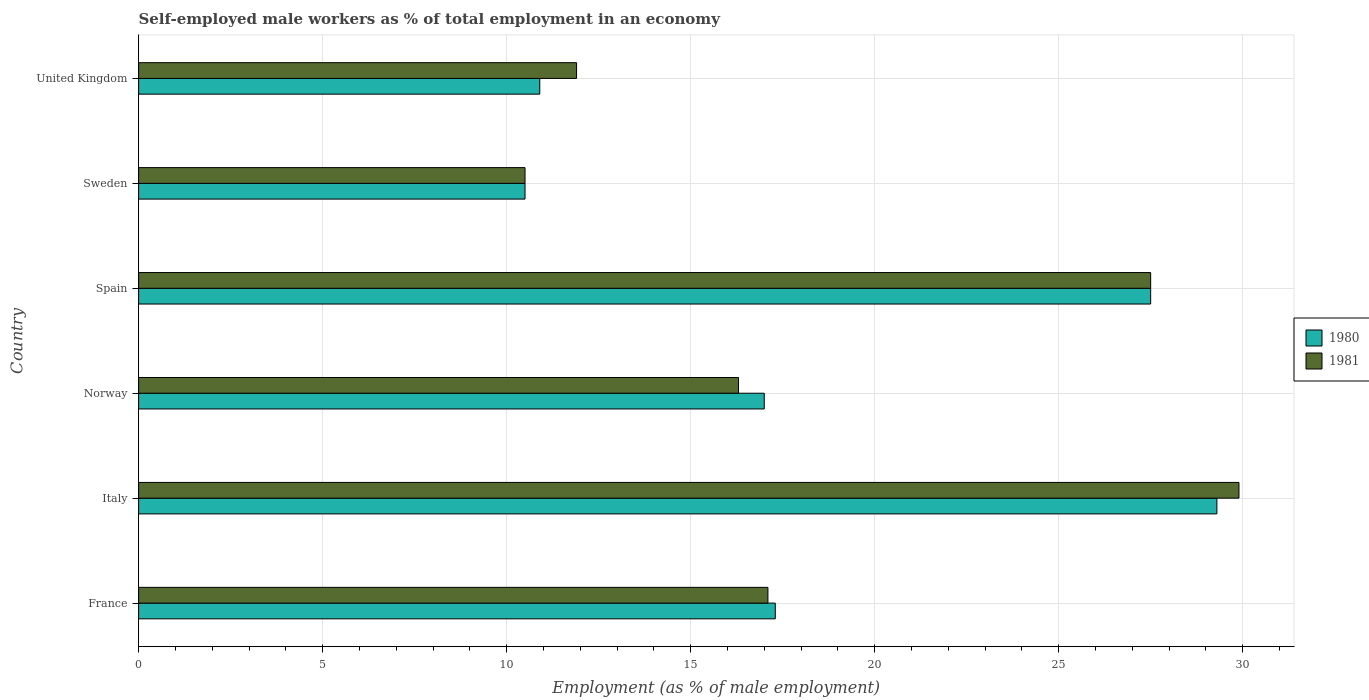How many groups of bars are there?
Your answer should be very brief. 6. How many bars are there on the 5th tick from the top?
Offer a very short reply. 2. How many bars are there on the 1st tick from the bottom?
Keep it short and to the point. 2. In how many cases, is the number of bars for a given country not equal to the number of legend labels?
Provide a short and direct response. 0. What is the percentage of self-employed male workers in 1980 in Norway?
Make the answer very short. 17. Across all countries, what is the maximum percentage of self-employed male workers in 1981?
Your answer should be very brief. 29.9. Across all countries, what is the minimum percentage of self-employed male workers in 1980?
Provide a short and direct response. 10.5. In which country was the percentage of self-employed male workers in 1981 maximum?
Offer a terse response. Italy. In which country was the percentage of self-employed male workers in 1981 minimum?
Offer a terse response. Sweden. What is the total percentage of self-employed male workers in 1980 in the graph?
Offer a terse response. 112.5. What is the difference between the percentage of self-employed male workers in 1980 in Italy and that in Norway?
Keep it short and to the point. 12.3. What is the difference between the percentage of self-employed male workers in 1981 in Norway and the percentage of self-employed male workers in 1980 in France?
Your answer should be very brief. -1. What is the average percentage of self-employed male workers in 1980 per country?
Offer a terse response. 18.75. What is the ratio of the percentage of self-employed male workers in 1980 in Italy to that in United Kingdom?
Your response must be concise. 2.69. Is the percentage of self-employed male workers in 1981 in Italy less than that in Spain?
Your response must be concise. No. What is the difference between the highest and the second highest percentage of self-employed male workers in 1981?
Offer a terse response. 2.4. What is the difference between the highest and the lowest percentage of self-employed male workers in 1980?
Offer a very short reply. 18.8. In how many countries, is the percentage of self-employed male workers in 1981 greater than the average percentage of self-employed male workers in 1981 taken over all countries?
Keep it short and to the point. 2. Is the sum of the percentage of self-employed male workers in 1980 in France and Italy greater than the maximum percentage of self-employed male workers in 1981 across all countries?
Your answer should be compact. Yes. Are all the bars in the graph horizontal?
Give a very brief answer. Yes. How many countries are there in the graph?
Keep it short and to the point. 6. What is the difference between two consecutive major ticks on the X-axis?
Make the answer very short. 5. How are the legend labels stacked?
Your answer should be compact. Vertical. What is the title of the graph?
Ensure brevity in your answer.  Self-employed male workers as % of total employment in an economy. Does "1961" appear as one of the legend labels in the graph?
Provide a short and direct response. No. What is the label or title of the X-axis?
Your answer should be compact. Employment (as % of male employment). What is the label or title of the Y-axis?
Your answer should be very brief. Country. What is the Employment (as % of male employment) of 1980 in France?
Keep it short and to the point. 17.3. What is the Employment (as % of male employment) of 1981 in France?
Keep it short and to the point. 17.1. What is the Employment (as % of male employment) of 1980 in Italy?
Your answer should be compact. 29.3. What is the Employment (as % of male employment) in 1981 in Italy?
Provide a short and direct response. 29.9. What is the Employment (as % of male employment) in 1981 in Norway?
Make the answer very short. 16.3. What is the Employment (as % of male employment) of 1981 in Spain?
Offer a very short reply. 27.5. What is the Employment (as % of male employment) of 1981 in Sweden?
Keep it short and to the point. 10.5. What is the Employment (as % of male employment) in 1980 in United Kingdom?
Make the answer very short. 10.9. What is the Employment (as % of male employment) in 1981 in United Kingdom?
Provide a succinct answer. 11.9. Across all countries, what is the maximum Employment (as % of male employment) in 1980?
Your answer should be compact. 29.3. Across all countries, what is the maximum Employment (as % of male employment) in 1981?
Your response must be concise. 29.9. Across all countries, what is the minimum Employment (as % of male employment) of 1981?
Offer a terse response. 10.5. What is the total Employment (as % of male employment) of 1980 in the graph?
Ensure brevity in your answer.  112.5. What is the total Employment (as % of male employment) in 1981 in the graph?
Make the answer very short. 113.2. What is the difference between the Employment (as % of male employment) in 1980 in France and that in Italy?
Your response must be concise. -12. What is the difference between the Employment (as % of male employment) of 1981 in France and that in Italy?
Offer a terse response. -12.8. What is the difference between the Employment (as % of male employment) in 1980 in France and that in Norway?
Offer a very short reply. 0.3. What is the difference between the Employment (as % of male employment) of 1980 in France and that in Spain?
Offer a terse response. -10.2. What is the difference between the Employment (as % of male employment) of 1980 in France and that in Sweden?
Your answer should be compact. 6.8. What is the difference between the Employment (as % of male employment) of 1980 in France and that in United Kingdom?
Give a very brief answer. 6.4. What is the difference between the Employment (as % of male employment) in 1981 in France and that in United Kingdom?
Give a very brief answer. 5.2. What is the difference between the Employment (as % of male employment) of 1980 in Italy and that in Norway?
Your answer should be very brief. 12.3. What is the difference between the Employment (as % of male employment) in 1981 in Italy and that in Spain?
Provide a succinct answer. 2.4. What is the difference between the Employment (as % of male employment) of 1980 in Italy and that in United Kingdom?
Your response must be concise. 18.4. What is the difference between the Employment (as % of male employment) in 1981 in Norway and that in Spain?
Your answer should be compact. -11.2. What is the difference between the Employment (as % of male employment) of 1980 in Norway and that in Sweden?
Provide a succinct answer. 6.5. What is the difference between the Employment (as % of male employment) in 1980 in Spain and that in Sweden?
Offer a terse response. 17. What is the difference between the Employment (as % of male employment) in 1981 in Spain and that in Sweden?
Your answer should be compact. 17. What is the difference between the Employment (as % of male employment) in 1980 in Spain and that in United Kingdom?
Make the answer very short. 16.6. What is the difference between the Employment (as % of male employment) in 1980 in Sweden and that in United Kingdom?
Your answer should be very brief. -0.4. What is the difference between the Employment (as % of male employment) of 1981 in Sweden and that in United Kingdom?
Keep it short and to the point. -1.4. What is the difference between the Employment (as % of male employment) of 1980 in France and the Employment (as % of male employment) of 1981 in Italy?
Offer a very short reply. -12.6. What is the difference between the Employment (as % of male employment) in 1980 in Italy and the Employment (as % of male employment) in 1981 in Spain?
Your response must be concise. 1.8. What is the difference between the Employment (as % of male employment) in 1980 in Italy and the Employment (as % of male employment) in 1981 in Sweden?
Ensure brevity in your answer.  18.8. What is the difference between the Employment (as % of male employment) of 1980 in Italy and the Employment (as % of male employment) of 1981 in United Kingdom?
Keep it short and to the point. 17.4. What is the difference between the Employment (as % of male employment) of 1980 in Norway and the Employment (as % of male employment) of 1981 in Sweden?
Provide a short and direct response. 6.5. What is the difference between the Employment (as % of male employment) in 1980 in Norway and the Employment (as % of male employment) in 1981 in United Kingdom?
Keep it short and to the point. 5.1. What is the difference between the Employment (as % of male employment) of 1980 in Spain and the Employment (as % of male employment) of 1981 in United Kingdom?
Make the answer very short. 15.6. What is the average Employment (as % of male employment) in 1980 per country?
Provide a succinct answer. 18.75. What is the average Employment (as % of male employment) in 1981 per country?
Provide a succinct answer. 18.87. What is the difference between the Employment (as % of male employment) in 1980 and Employment (as % of male employment) in 1981 in Italy?
Keep it short and to the point. -0.6. What is the difference between the Employment (as % of male employment) of 1980 and Employment (as % of male employment) of 1981 in Spain?
Give a very brief answer. 0. What is the difference between the Employment (as % of male employment) in 1980 and Employment (as % of male employment) in 1981 in Sweden?
Your answer should be compact. 0. What is the difference between the Employment (as % of male employment) of 1980 and Employment (as % of male employment) of 1981 in United Kingdom?
Offer a very short reply. -1. What is the ratio of the Employment (as % of male employment) in 1980 in France to that in Italy?
Your answer should be compact. 0.59. What is the ratio of the Employment (as % of male employment) of 1981 in France to that in Italy?
Make the answer very short. 0.57. What is the ratio of the Employment (as % of male employment) in 1980 in France to that in Norway?
Provide a short and direct response. 1.02. What is the ratio of the Employment (as % of male employment) in 1981 in France to that in Norway?
Provide a succinct answer. 1.05. What is the ratio of the Employment (as % of male employment) of 1980 in France to that in Spain?
Keep it short and to the point. 0.63. What is the ratio of the Employment (as % of male employment) in 1981 in France to that in Spain?
Your answer should be compact. 0.62. What is the ratio of the Employment (as % of male employment) in 1980 in France to that in Sweden?
Offer a terse response. 1.65. What is the ratio of the Employment (as % of male employment) in 1981 in France to that in Sweden?
Offer a terse response. 1.63. What is the ratio of the Employment (as % of male employment) of 1980 in France to that in United Kingdom?
Offer a very short reply. 1.59. What is the ratio of the Employment (as % of male employment) of 1981 in France to that in United Kingdom?
Offer a very short reply. 1.44. What is the ratio of the Employment (as % of male employment) of 1980 in Italy to that in Norway?
Make the answer very short. 1.72. What is the ratio of the Employment (as % of male employment) of 1981 in Italy to that in Norway?
Make the answer very short. 1.83. What is the ratio of the Employment (as % of male employment) of 1980 in Italy to that in Spain?
Provide a succinct answer. 1.07. What is the ratio of the Employment (as % of male employment) of 1981 in Italy to that in Spain?
Offer a very short reply. 1.09. What is the ratio of the Employment (as % of male employment) of 1980 in Italy to that in Sweden?
Offer a very short reply. 2.79. What is the ratio of the Employment (as % of male employment) in 1981 in Italy to that in Sweden?
Offer a terse response. 2.85. What is the ratio of the Employment (as % of male employment) in 1980 in Italy to that in United Kingdom?
Offer a very short reply. 2.69. What is the ratio of the Employment (as % of male employment) in 1981 in Italy to that in United Kingdom?
Your answer should be very brief. 2.51. What is the ratio of the Employment (as % of male employment) in 1980 in Norway to that in Spain?
Your response must be concise. 0.62. What is the ratio of the Employment (as % of male employment) in 1981 in Norway to that in Spain?
Provide a succinct answer. 0.59. What is the ratio of the Employment (as % of male employment) of 1980 in Norway to that in Sweden?
Your response must be concise. 1.62. What is the ratio of the Employment (as % of male employment) of 1981 in Norway to that in Sweden?
Ensure brevity in your answer.  1.55. What is the ratio of the Employment (as % of male employment) of 1980 in Norway to that in United Kingdom?
Give a very brief answer. 1.56. What is the ratio of the Employment (as % of male employment) in 1981 in Norway to that in United Kingdom?
Provide a succinct answer. 1.37. What is the ratio of the Employment (as % of male employment) in 1980 in Spain to that in Sweden?
Your response must be concise. 2.62. What is the ratio of the Employment (as % of male employment) in 1981 in Spain to that in Sweden?
Offer a terse response. 2.62. What is the ratio of the Employment (as % of male employment) in 1980 in Spain to that in United Kingdom?
Ensure brevity in your answer.  2.52. What is the ratio of the Employment (as % of male employment) in 1981 in Spain to that in United Kingdom?
Keep it short and to the point. 2.31. What is the ratio of the Employment (as % of male employment) of 1980 in Sweden to that in United Kingdom?
Offer a terse response. 0.96. What is the ratio of the Employment (as % of male employment) in 1981 in Sweden to that in United Kingdom?
Keep it short and to the point. 0.88. What is the difference between the highest and the second highest Employment (as % of male employment) in 1981?
Ensure brevity in your answer.  2.4. 